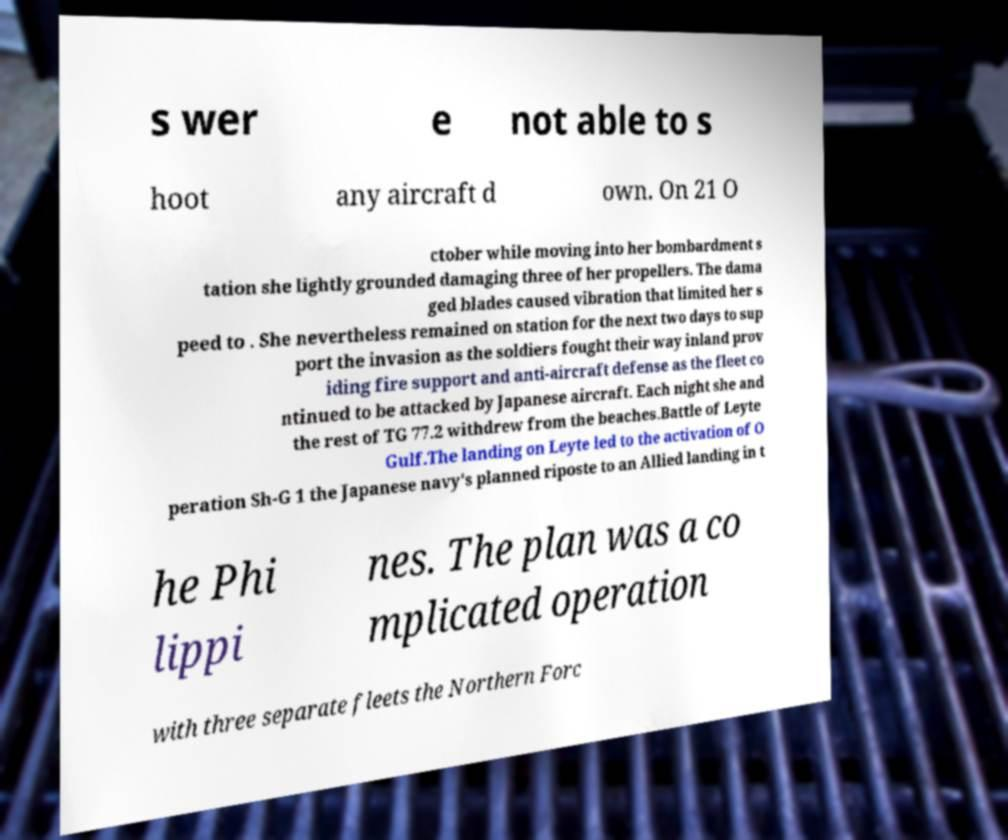What messages or text are displayed in this image? I need them in a readable, typed format. s wer e not able to s hoot any aircraft d own. On 21 O ctober while moving into her bombardment s tation she lightly grounded damaging three of her propellers. The dama ged blades caused vibration that limited her s peed to . She nevertheless remained on station for the next two days to sup port the invasion as the soldiers fought their way inland prov iding fire support and anti-aircraft defense as the fleet co ntinued to be attacked by Japanese aircraft. Each night she and the rest of TG 77.2 withdrew from the beaches.Battle of Leyte Gulf.The landing on Leyte led to the activation of O peration Sh-G 1 the Japanese navy's planned riposte to an Allied landing in t he Phi lippi nes. The plan was a co mplicated operation with three separate fleets the Northern Forc 